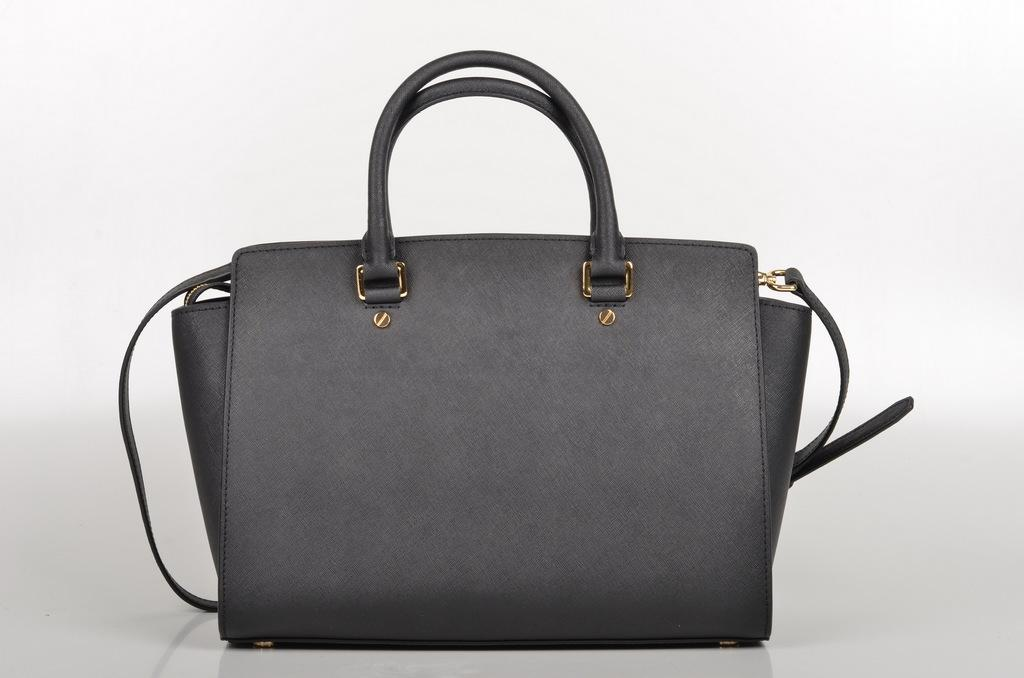What is the color of the bag in the image? The bag in the image is grey. What feature of the bag allows it to be carried? The bag has a handle and a strap for carrying. What type of crime is being committed in the image? There is no crime present in the image; it features a grey color bag with a handle and a strap. What type of stove is visible in the image? There is no stove present in the image; it only features a grey color bag with a handle and a strap. 